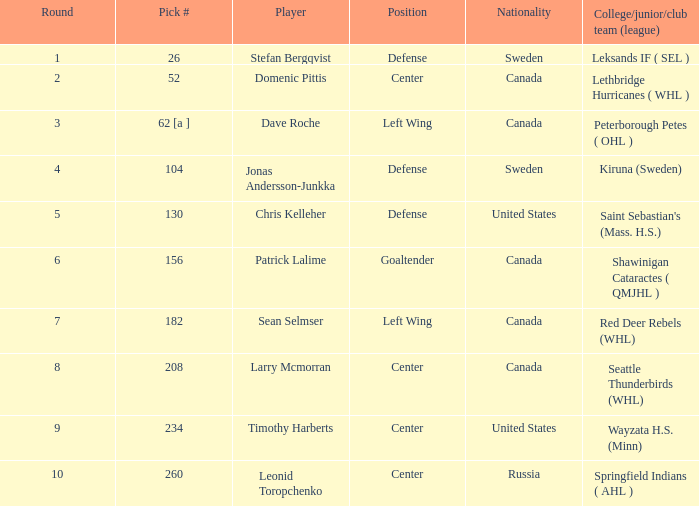What is the nationality of the player whose college/junior/club team (league) is Seattle Thunderbirds (WHL)? Canada. 